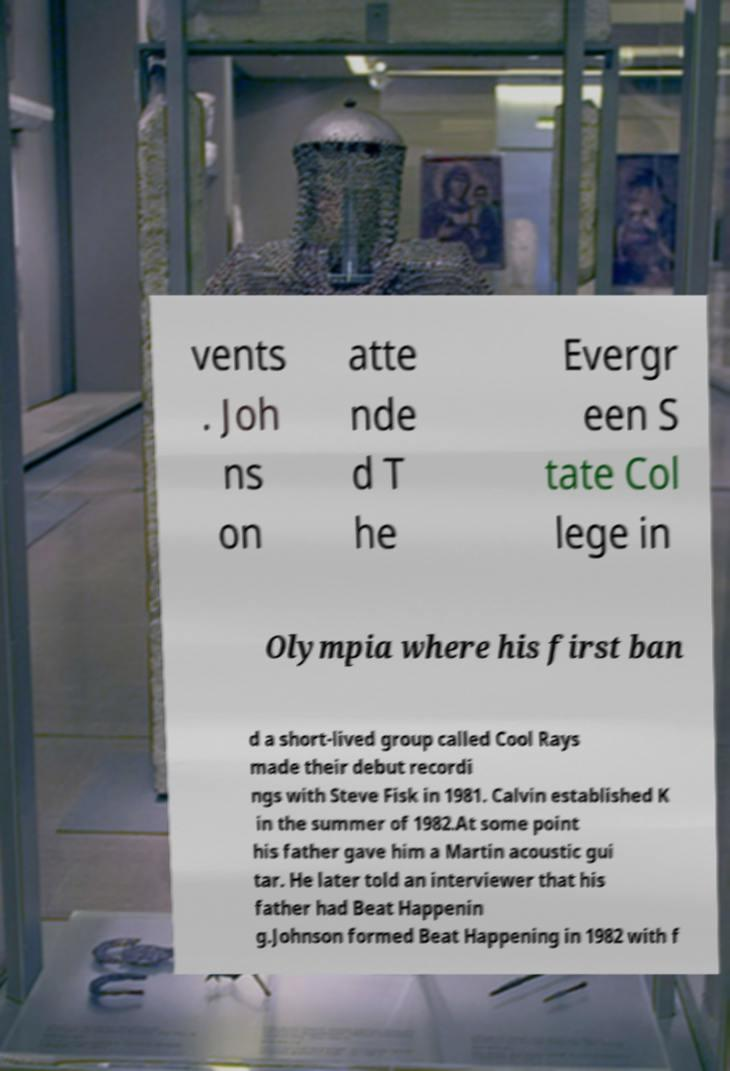What messages or text are displayed in this image? I need them in a readable, typed format. vents . Joh ns on atte nde d T he Evergr een S tate Col lege in Olympia where his first ban d a short-lived group called Cool Rays made their debut recordi ngs with Steve Fisk in 1981. Calvin established K in the summer of 1982.At some point his father gave him a Martin acoustic gui tar. He later told an interviewer that his father had Beat Happenin g.Johnson formed Beat Happening in 1982 with f 